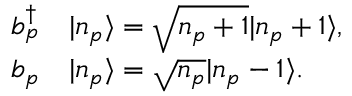Convert formula to latex. <formula><loc_0><loc_0><loc_500><loc_500>\begin{array} { r l } { b _ { p } ^ { \dagger } } & | n _ { p } \rangle = \sqrt { n _ { p } + 1 } | n _ { p } + 1 \rangle , } \\ { b _ { p } } & | n _ { p } \rangle = \sqrt { n _ { p } } | n _ { p } - 1 \rangle . } \end{array}</formula> 